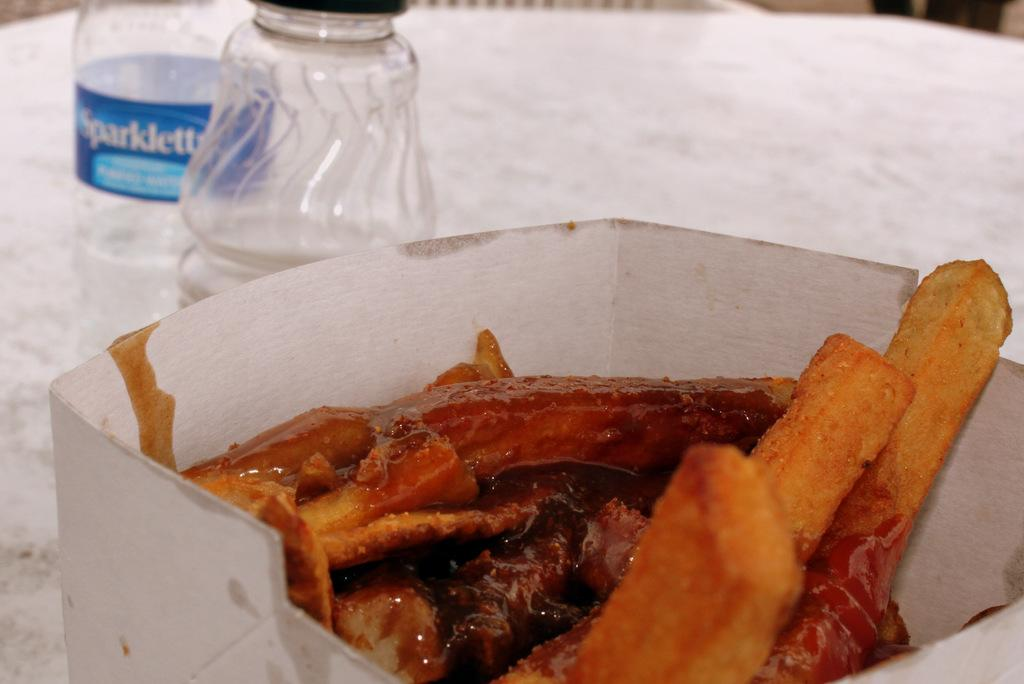<image>
Create a compact narrative representing the image presented. A bottle of Sparklette water sits behind a carton of food. 